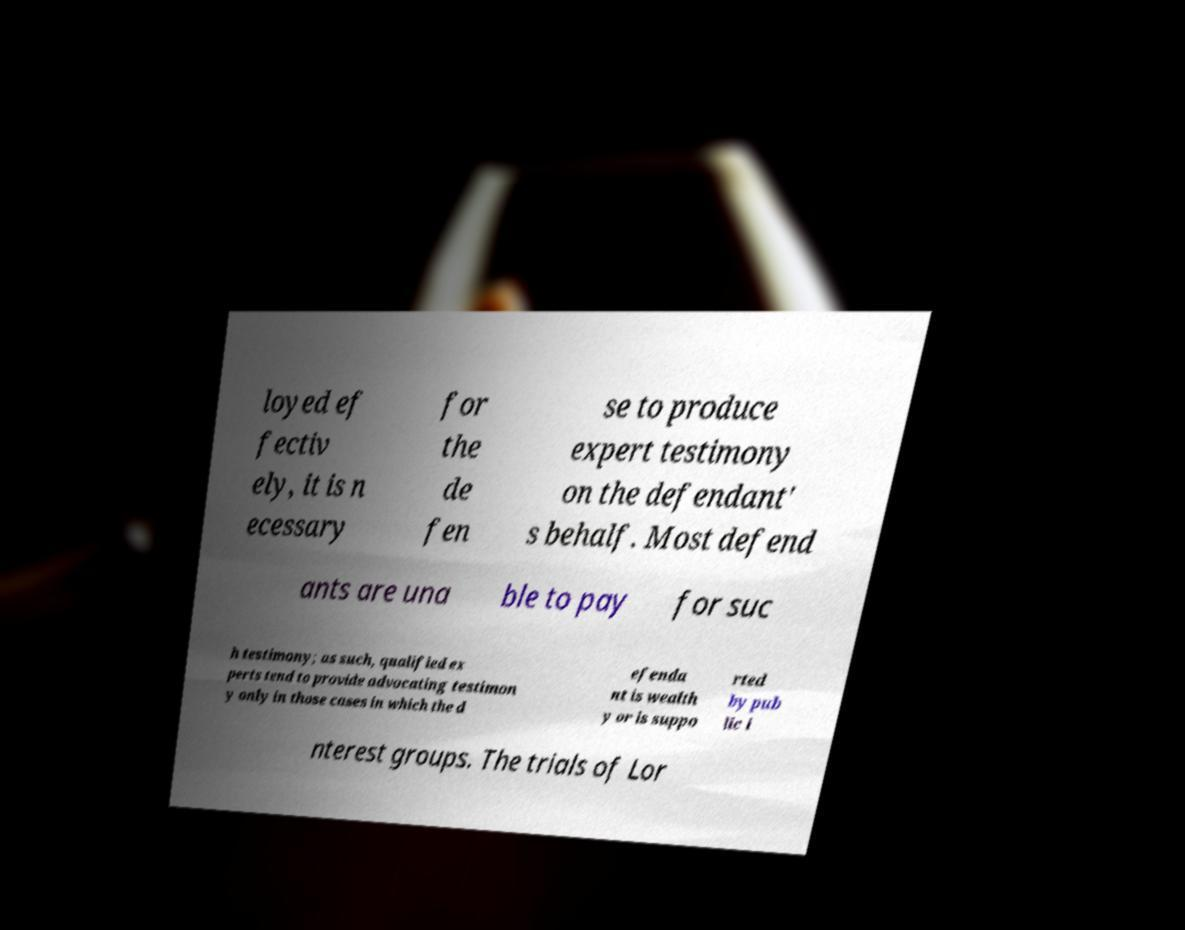I need the written content from this picture converted into text. Can you do that? loyed ef fectiv ely, it is n ecessary for the de fen se to produce expert testimony on the defendant' s behalf. Most defend ants are una ble to pay for suc h testimony; as such, qualified ex perts tend to provide advocating testimon y only in those cases in which the d efenda nt is wealth y or is suppo rted by pub lic i nterest groups. The trials of Lor 